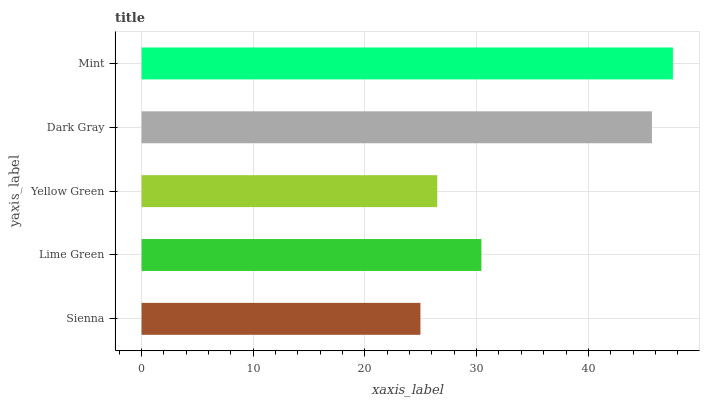Is Sienna the minimum?
Answer yes or no. Yes. Is Mint the maximum?
Answer yes or no. Yes. Is Lime Green the minimum?
Answer yes or no. No. Is Lime Green the maximum?
Answer yes or no. No. Is Lime Green greater than Sienna?
Answer yes or no. Yes. Is Sienna less than Lime Green?
Answer yes or no. Yes. Is Sienna greater than Lime Green?
Answer yes or no. No. Is Lime Green less than Sienna?
Answer yes or no. No. Is Lime Green the high median?
Answer yes or no. Yes. Is Lime Green the low median?
Answer yes or no. Yes. Is Dark Gray the high median?
Answer yes or no. No. Is Sienna the low median?
Answer yes or no. No. 